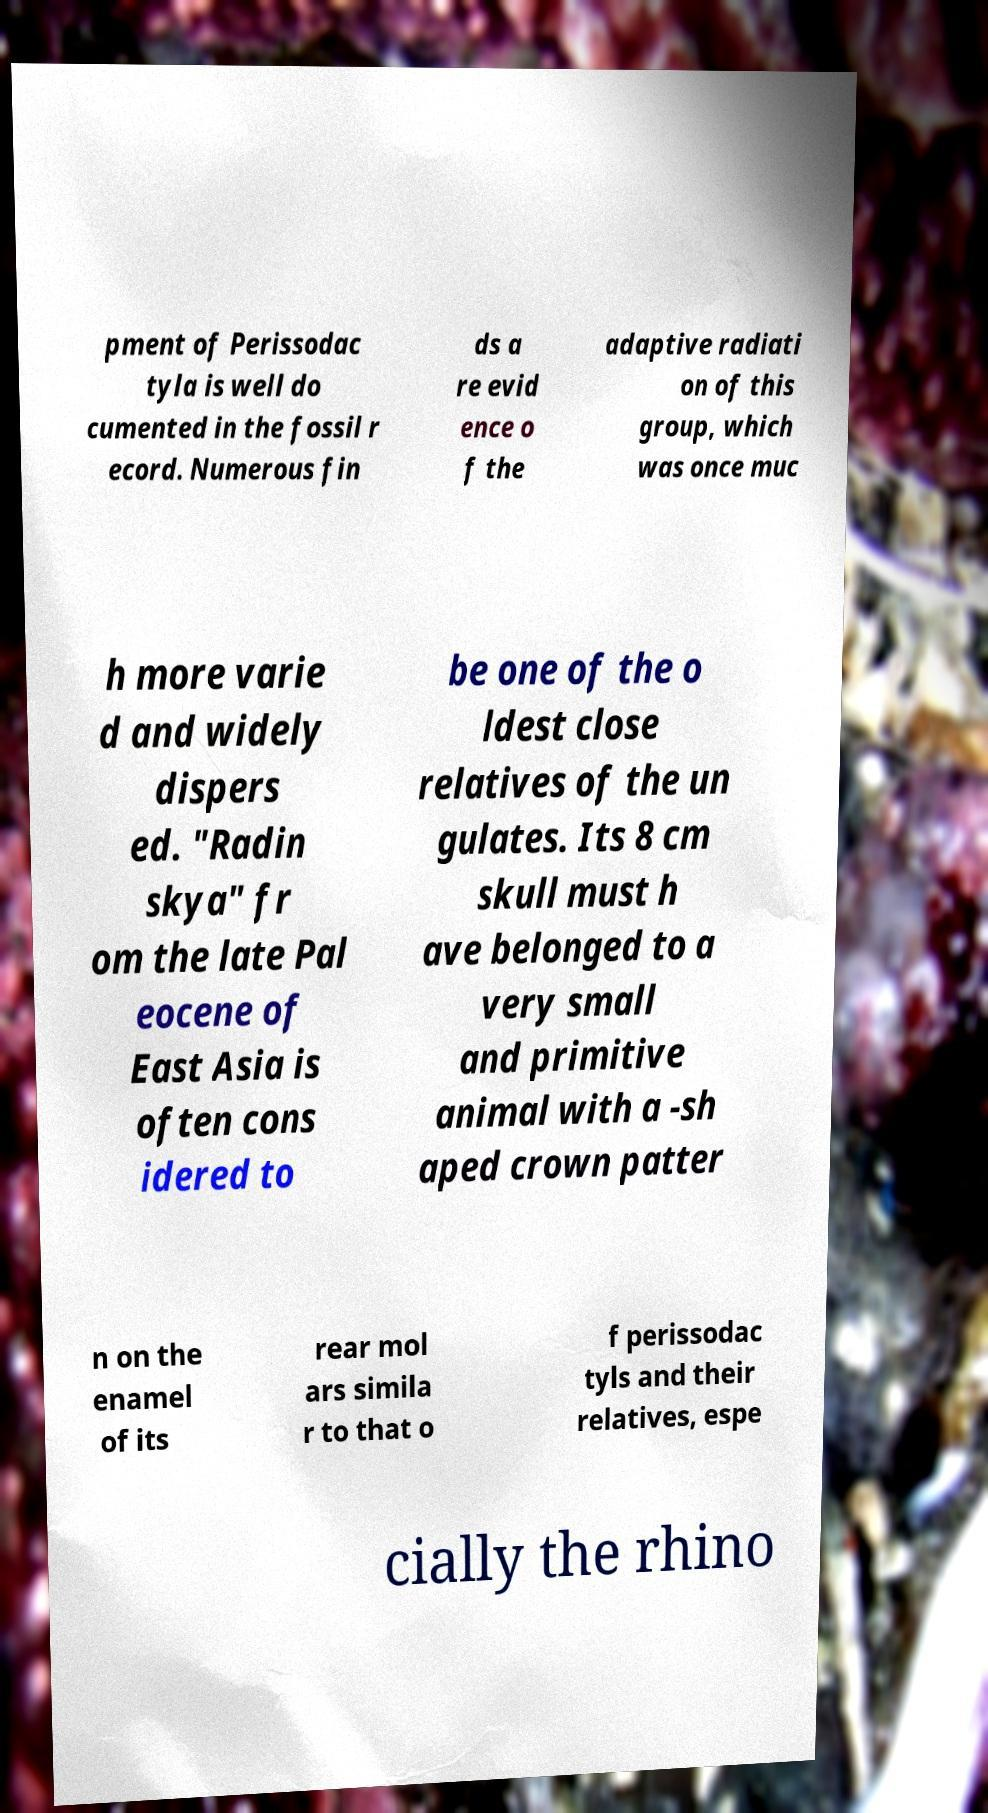Can you read and provide the text displayed in the image?This photo seems to have some interesting text. Can you extract and type it out for me? pment of Perissodac tyla is well do cumented in the fossil r ecord. Numerous fin ds a re evid ence o f the adaptive radiati on of this group, which was once muc h more varie d and widely dispers ed. "Radin skya" fr om the late Pal eocene of East Asia is often cons idered to be one of the o ldest close relatives of the un gulates. Its 8 cm skull must h ave belonged to a very small and primitive animal with a -sh aped crown patter n on the enamel of its rear mol ars simila r to that o f perissodac tyls and their relatives, espe cially the rhino 